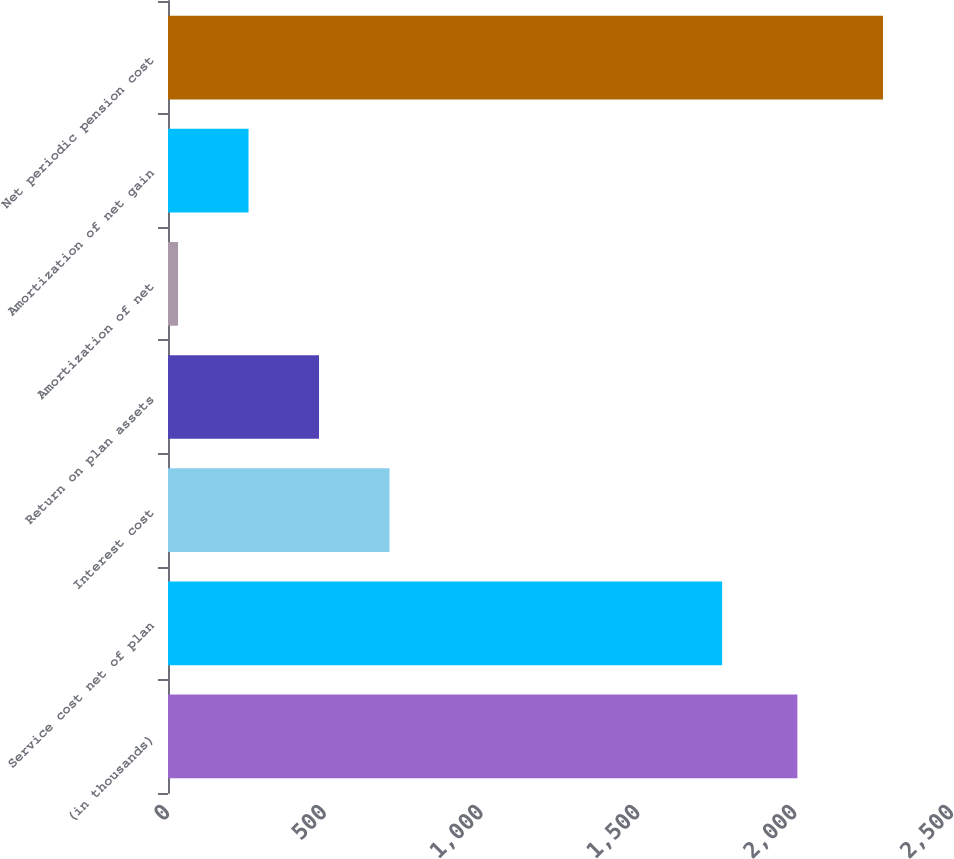Convert chart to OTSL. <chart><loc_0><loc_0><loc_500><loc_500><bar_chart><fcel>(in thousands)<fcel>Service cost net of plan<fcel>Interest cost<fcel>Return on plan assets<fcel>Amortization of net<fcel>Amortization of net gain<fcel>Net periodic pension cost<nl><fcel>2007<fcel>1767<fcel>706.4<fcel>481.6<fcel>32<fcel>256.8<fcel>2280<nl></chart> 